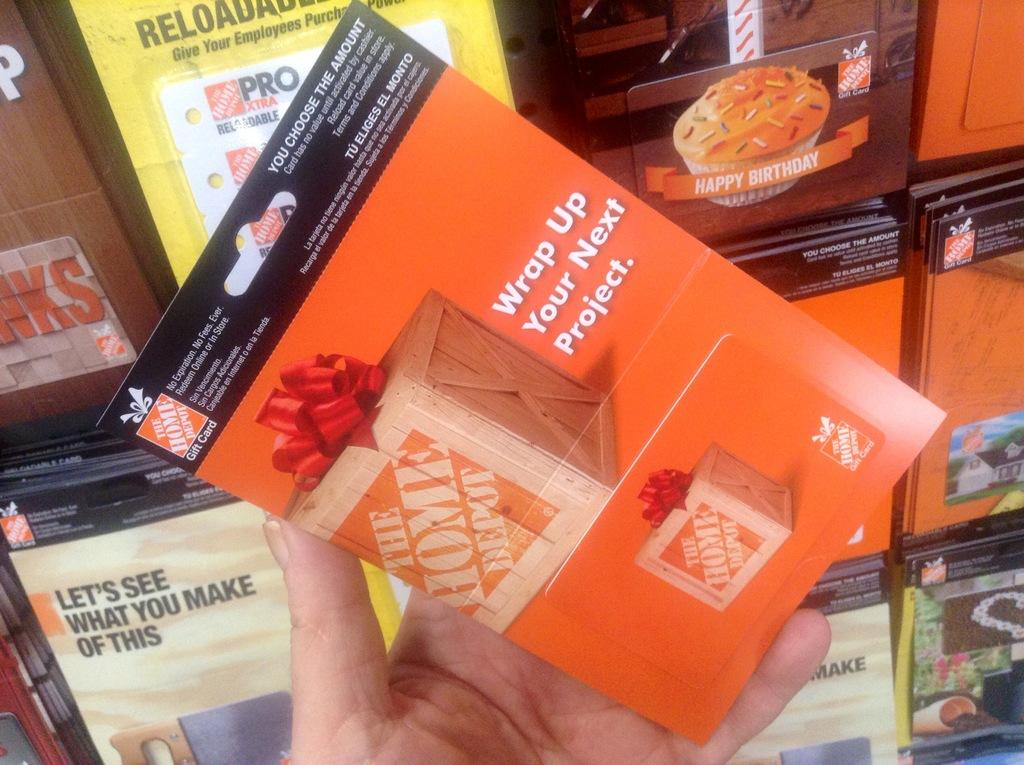What objects are present in the image? There are cards in the image. What is featured on the cards? There are advertisements on the cards. Can you describe the person in the image? There is a person holding a card in the image. What type of cook is visible in the image? There is no cook present in the image. What book is the person reading in the image? There is no book present in the image. What type of breakfast is being prepared in the image? There is no breakfast preparation visible in the image. 